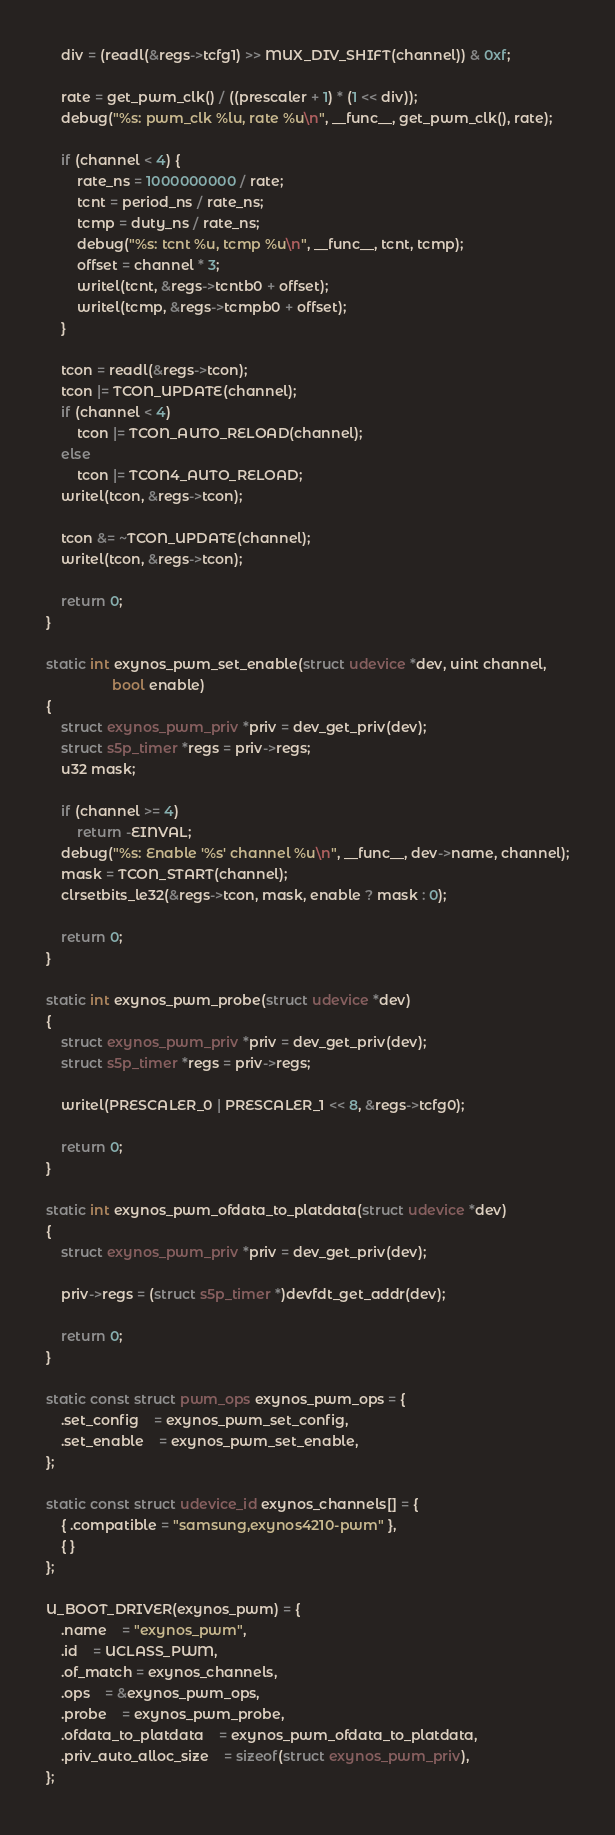<code> <loc_0><loc_0><loc_500><loc_500><_C_>	div = (readl(&regs->tcfg1) >> MUX_DIV_SHIFT(channel)) & 0xf;

	rate = get_pwm_clk() / ((prescaler + 1) * (1 << div));
	debug("%s: pwm_clk %lu, rate %u\n", __func__, get_pwm_clk(), rate);

	if (channel < 4) {
		rate_ns = 1000000000 / rate;
		tcnt = period_ns / rate_ns;
		tcmp = duty_ns / rate_ns;
		debug("%s: tcnt %u, tcmp %u\n", __func__, tcnt, tcmp);
		offset = channel * 3;
		writel(tcnt, &regs->tcntb0 + offset);
		writel(tcmp, &regs->tcmpb0 + offset);
	}

	tcon = readl(&regs->tcon);
	tcon |= TCON_UPDATE(channel);
	if (channel < 4)
		tcon |= TCON_AUTO_RELOAD(channel);
	else
		tcon |= TCON4_AUTO_RELOAD;
	writel(tcon, &regs->tcon);

	tcon &= ~TCON_UPDATE(channel);
	writel(tcon, &regs->tcon);

	return 0;
}

static int exynos_pwm_set_enable(struct udevice *dev, uint channel,
				 bool enable)
{
	struct exynos_pwm_priv *priv = dev_get_priv(dev);
	struct s5p_timer *regs = priv->regs;
	u32 mask;

	if (channel >= 4)
		return -EINVAL;
	debug("%s: Enable '%s' channel %u\n", __func__, dev->name, channel);
	mask = TCON_START(channel);
	clrsetbits_le32(&regs->tcon, mask, enable ? mask : 0);

	return 0;
}

static int exynos_pwm_probe(struct udevice *dev)
{
	struct exynos_pwm_priv *priv = dev_get_priv(dev);
	struct s5p_timer *regs = priv->regs;

	writel(PRESCALER_0 | PRESCALER_1 << 8, &regs->tcfg0);

	return 0;
}

static int exynos_pwm_ofdata_to_platdata(struct udevice *dev)
{
	struct exynos_pwm_priv *priv = dev_get_priv(dev);

	priv->regs = (struct s5p_timer *)devfdt_get_addr(dev);

	return 0;
}

static const struct pwm_ops exynos_pwm_ops = {
	.set_config	= exynos_pwm_set_config,
	.set_enable	= exynos_pwm_set_enable,
};

static const struct udevice_id exynos_channels[] = {
	{ .compatible = "samsung,exynos4210-pwm" },
	{ }
};

U_BOOT_DRIVER(exynos_pwm) = {
	.name	= "exynos_pwm",
	.id	= UCLASS_PWM,
	.of_match = exynos_channels,
	.ops	= &exynos_pwm_ops,
	.probe	= exynos_pwm_probe,
	.ofdata_to_platdata	= exynos_pwm_ofdata_to_platdata,
	.priv_auto_alloc_size	= sizeof(struct exynos_pwm_priv),
};
</code> 